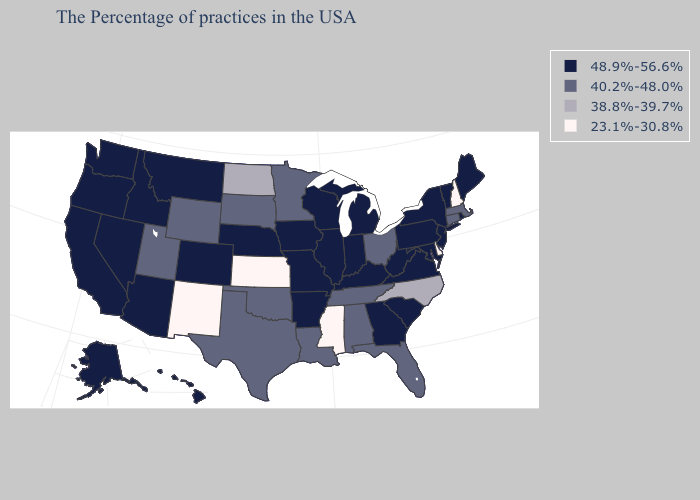Name the states that have a value in the range 48.9%-56.6%?
Be succinct. Maine, Rhode Island, Vermont, New York, New Jersey, Maryland, Pennsylvania, Virginia, South Carolina, West Virginia, Georgia, Michigan, Kentucky, Indiana, Wisconsin, Illinois, Missouri, Arkansas, Iowa, Nebraska, Colorado, Montana, Arizona, Idaho, Nevada, California, Washington, Oregon, Alaska, Hawaii. Name the states that have a value in the range 40.2%-48.0%?
Quick response, please. Massachusetts, Connecticut, Ohio, Florida, Alabama, Tennessee, Louisiana, Minnesota, Oklahoma, Texas, South Dakota, Wyoming, Utah. What is the value of Missouri?
Quick response, please. 48.9%-56.6%. What is the value of Iowa?
Concise answer only. 48.9%-56.6%. What is the lowest value in the USA?
Quick response, please. 23.1%-30.8%. Does the map have missing data?
Give a very brief answer. No. What is the highest value in states that border Mississippi?
Be succinct. 48.9%-56.6%. How many symbols are there in the legend?
Write a very short answer. 4. Name the states that have a value in the range 23.1%-30.8%?
Answer briefly. New Hampshire, Delaware, Mississippi, Kansas, New Mexico. What is the lowest value in states that border New Jersey?
Short answer required. 23.1%-30.8%. What is the value of Rhode Island?
Give a very brief answer. 48.9%-56.6%. Which states have the lowest value in the USA?
Be succinct. New Hampshire, Delaware, Mississippi, Kansas, New Mexico. Which states have the lowest value in the Northeast?
Answer briefly. New Hampshire. Name the states that have a value in the range 23.1%-30.8%?
Quick response, please. New Hampshire, Delaware, Mississippi, Kansas, New Mexico. Does New Hampshire have the lowest value in the Northeast?
Keep it brief. Yes. 